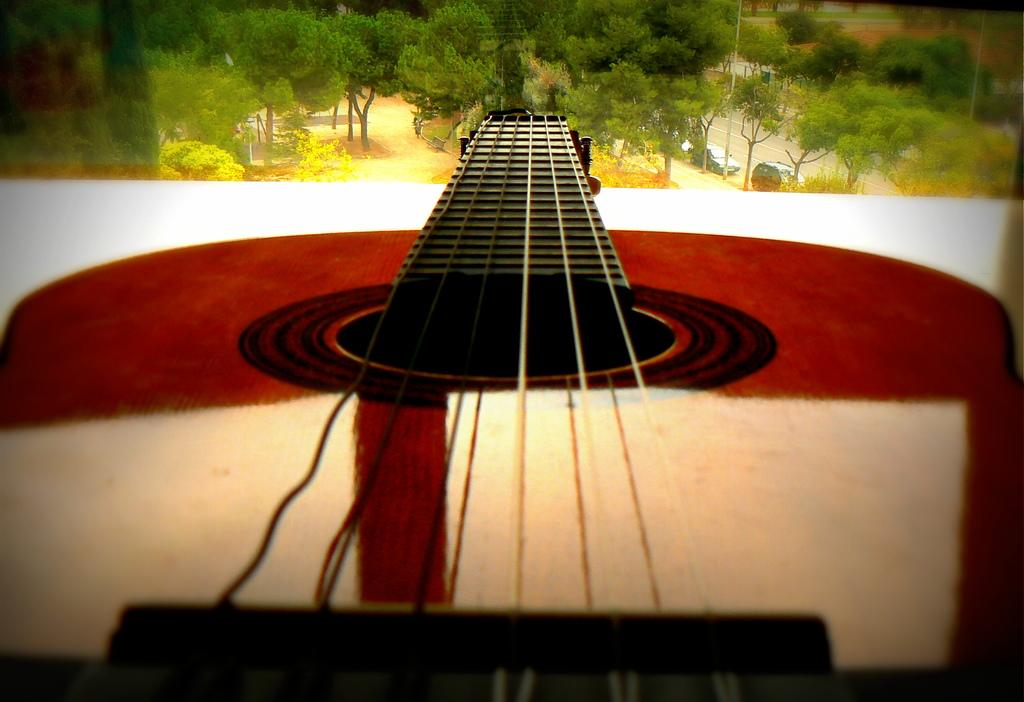What musical instrument is present in the image? There is a guitar in the image. Where is the guitar located? The guitar is placed on a table. What type of natural environment can be seen in the image? Trees, plants, grass, and a road are visible in the image. What man-made structure can be seen in the image? There is a pole in the image. What are the parked vehicles in the image? Cars are parked beside the road in the image. How many lizards are crawling on the guitar in the image? There are no lizards present in the image; the guitar is placed on a table. What type of cloud can be seen in the image? There is no cloud visible in the image; the sky is not mentioned in the provided facts. 